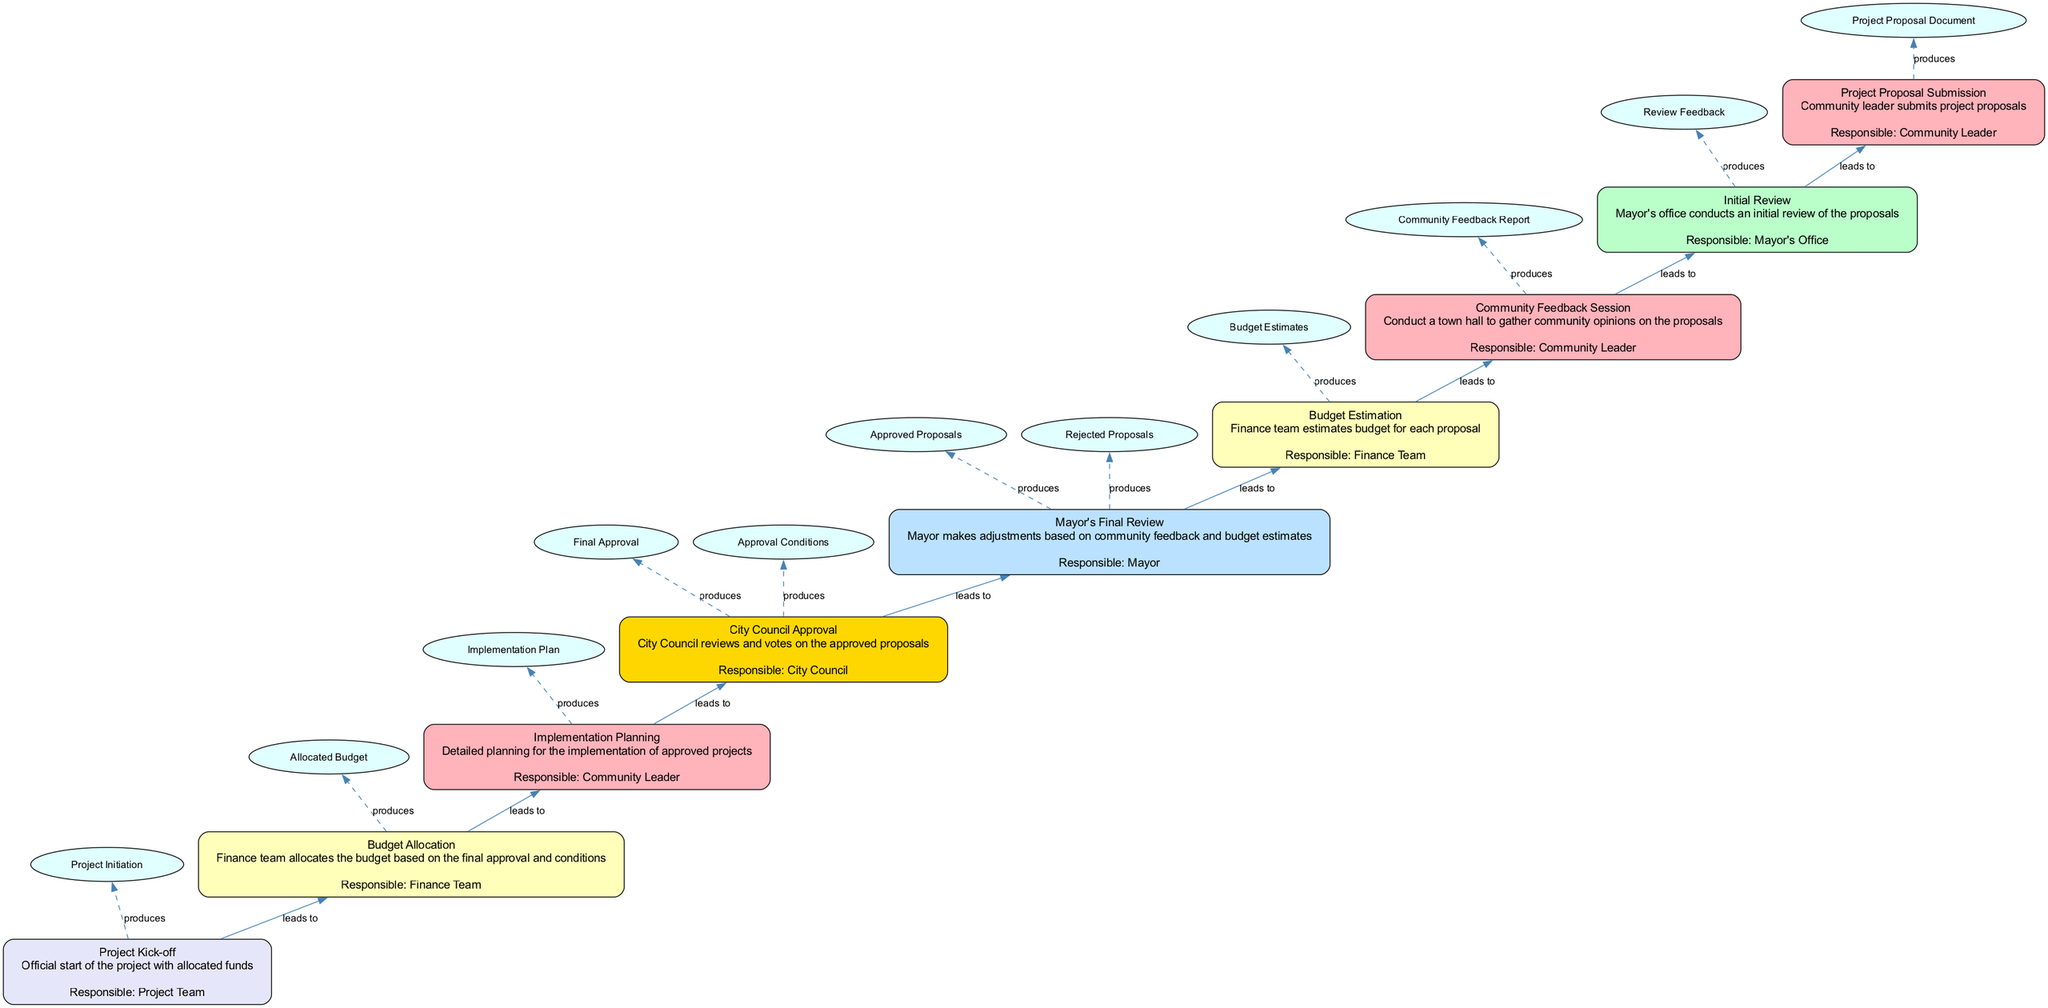What is the first step in the budget approval process? The first step in the diagram is the "Project Proposal Submission", indicating it's the starting point of the process.
Answer: Project Proposal Submission How many outputs does the "Budget Estimation" step produce? The "Budget Estimation" step has one output listed, which is "Budget Estimates".
Answer: 1 Who is responsible for the "Community Feedback Session"? The responsible party for the "Community Feedback Session" is the "Community Leader", as indicated in the step description.
Answer: Community Leader What leads to the "Implementation Planning"? The "City Council Approval" step leads to "Implementation Planning", meaning it's the direct predecessor step in the process.
Answer: City Council Approval Which step produces both "Approved Proposals" and "Rejected Proposals"? The step that produces both "Approved Proposals" and "Rejected Proposals" is "Mayor's Final Review", as it involves the mayor's assessment and final decisions.
Answer: Mayor's Final Review What is the final output of the entire process? The final output of the process is "Project Initiation", which is the result of the "Project Kick-off" step.
Answer: Project Initiation Which party is involved in the final review of proposals? The final review of proposals is conducted by the "Mayor", as seen in the "Mayor's Final Review" step.
Answer: Mayor What is the last step that involves budget-related activities? The last step that involves budget-related activities is "Budget Allocation", as it's specifically concerned with allocating the obtained budget.
Answer: Budget Allocation 